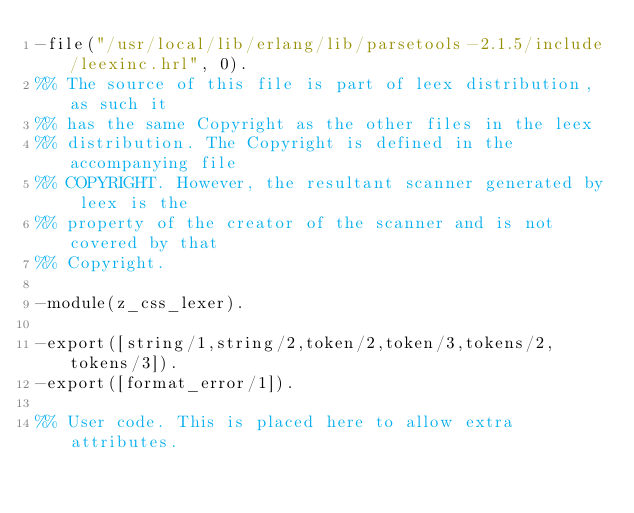Convert code to text. <code><loc_0><loc_0><loc_500><loc_500><_Erlang_>-file("/usr/local/lib/erlang/lib/parsetools-2.1.5/include/leexinc.hrl", 0).
%% The source of this file is part of leex distribution, as such it
%% has the same Copyright as the other files in the leex
%% distribution. The Copyright is defined in the accompanying file
%% COPYRIGHT. However, the resultant scanner generated by leex is the
%% property of the creator of the scanner and is not covered by that
%% Copyright.

-module(z_css_lexer).

-export([string/1,string/2,token/2,token/3,tokens/2,tokens/3]).
-export([format_error/1]).

%% User code. This is placed here to allow extra attributes.</code> 